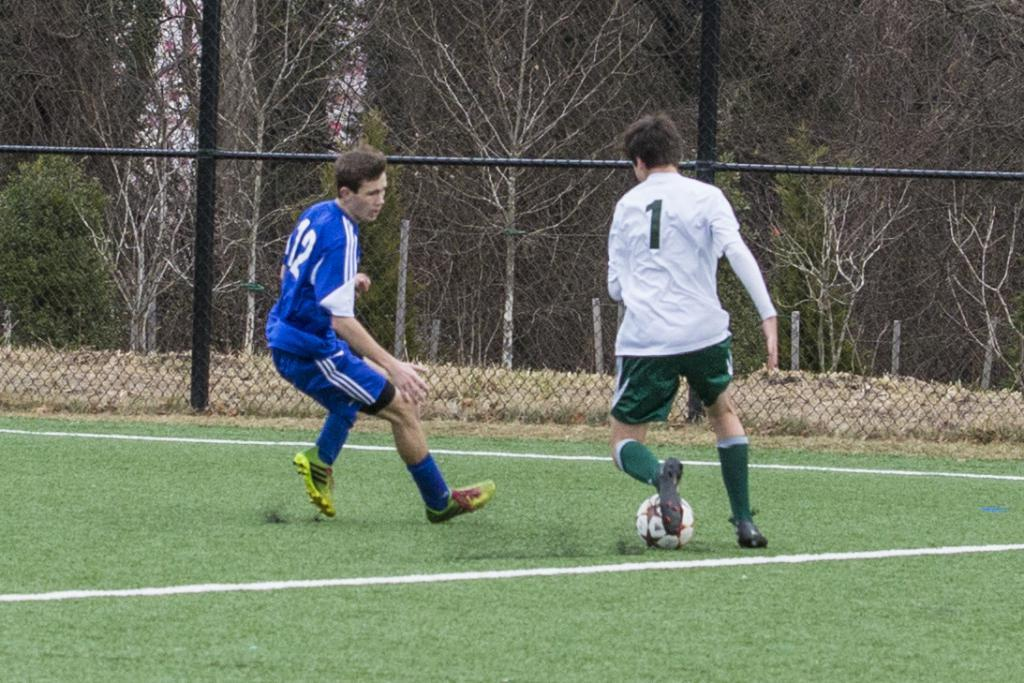How many people are in the image? There are two men in the image. What are the men doing in the image? The men are playing with a ball. Where is the ball located in the image? The ball is on the ground. What can be seen in the background of the image? There is a fence and trees in the background of the image. What type of pin is being used in the image? There is no pin present in the image. 